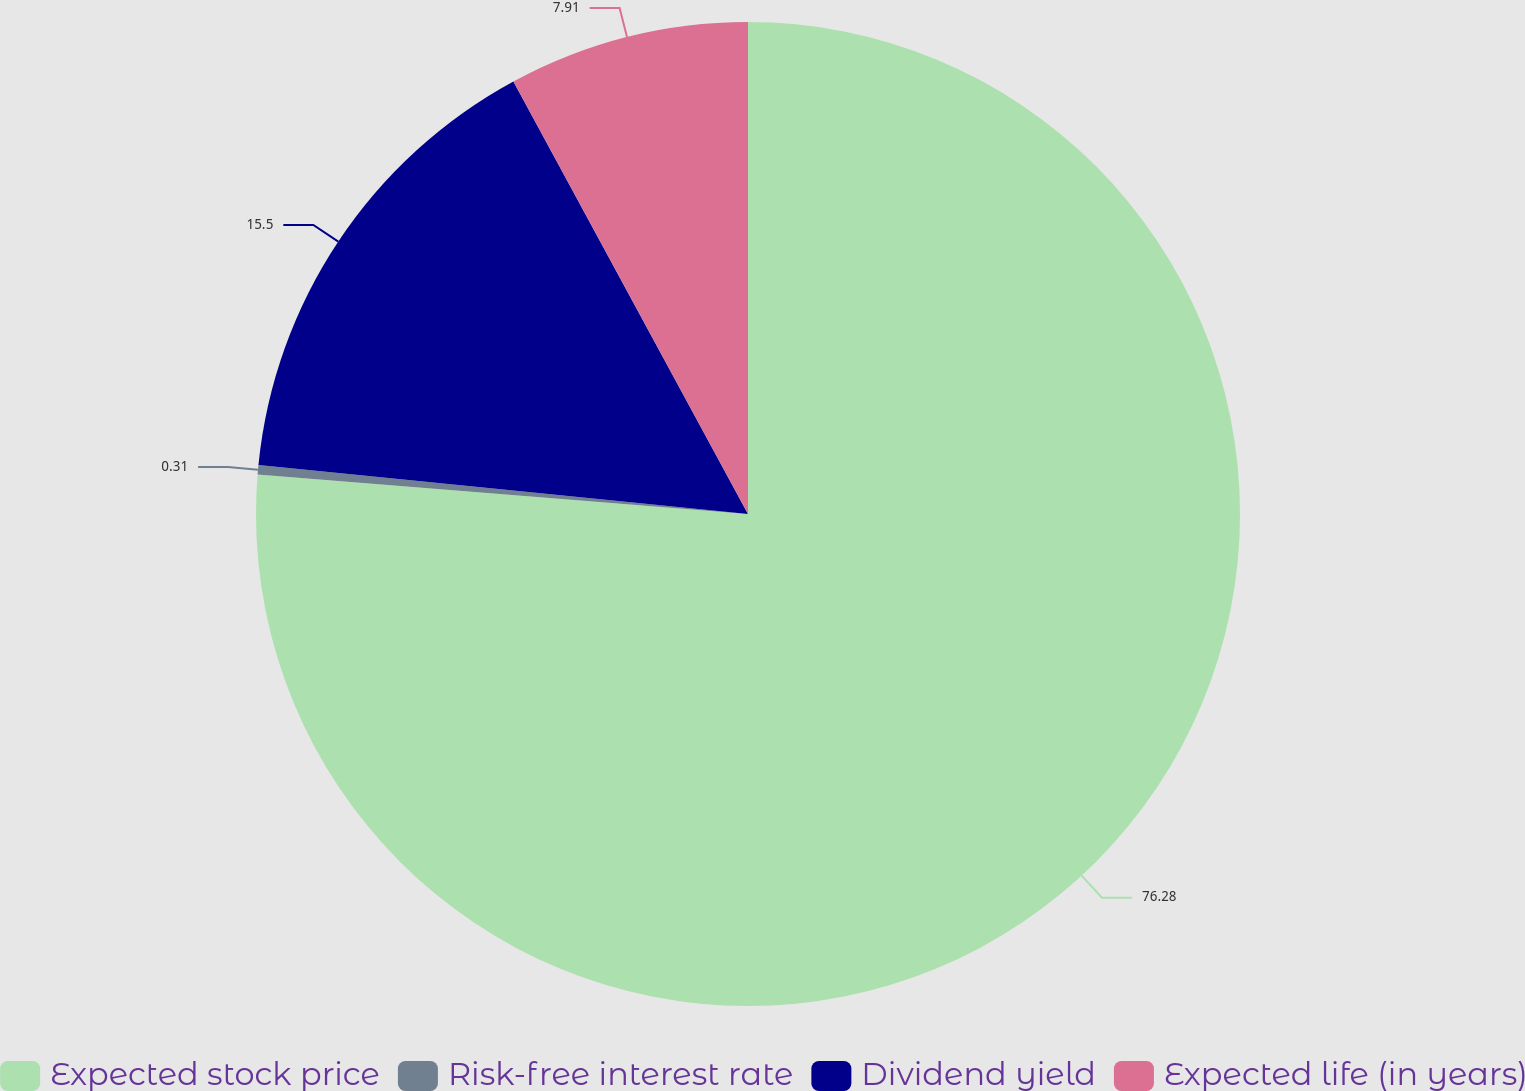Convert chart to OTSL. <chart><loc_0><loc_0><loc_500><loc_500><pie_chart><fcel>Expected stock price<fcel>Risk-free interest rate<fcel>Dividend yield<fcel>Expected life (in years)<nl><fcel>76.28%<fcel>0.31%<fcel>15.5%<fcel>7.91%<nl></chart> 